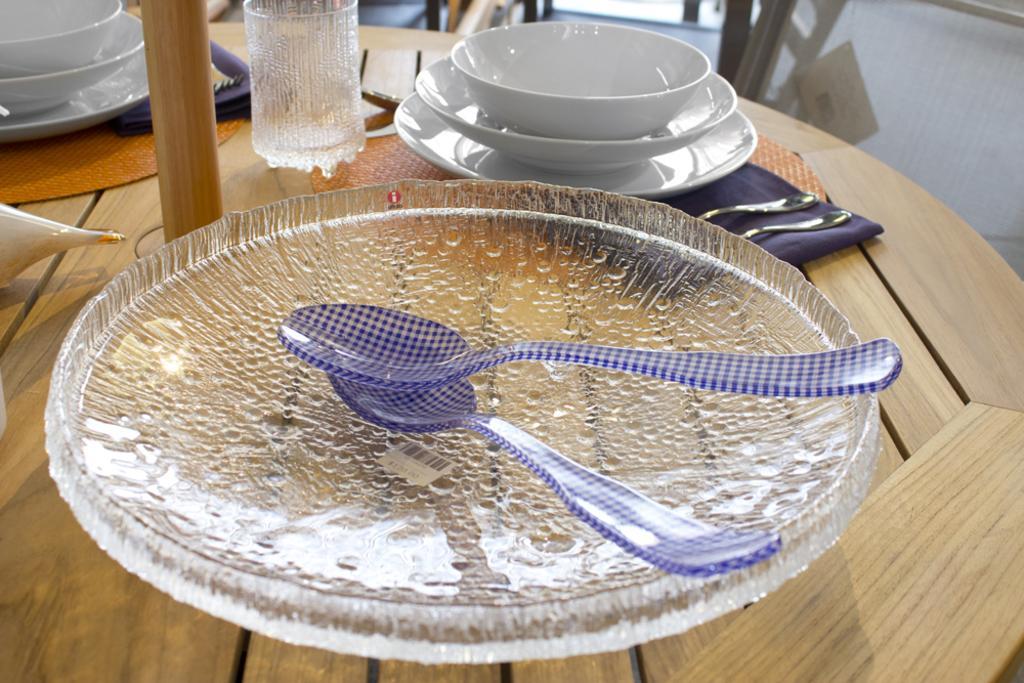In one or two sentences, can you explain what this image depicts? In this image at the bottom there is a table, on the table there is a plate, spoons, bowls, cloths, glass and one wooden stick. And in the background there are some objects. 